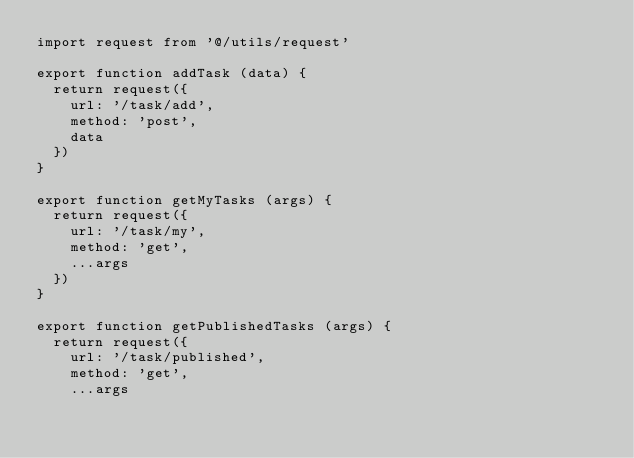Convert code to text. <code><loc_0><loc_0><loc_500><loc_500><_JavaScript_>import request from '@/utils/request'

export function addTask (data) {
  return request({
    url: '/task/add',
    method: 'post',
    data
  })
}

export function getMyTasks (args) {
  return request({
    url: '/task/my',
    method: 'get',
    ...args
  })
}

export function getPublishedTasks (args) {
  return request({
    url: '/task/published',
    method: 'get',
    ...args</code> 